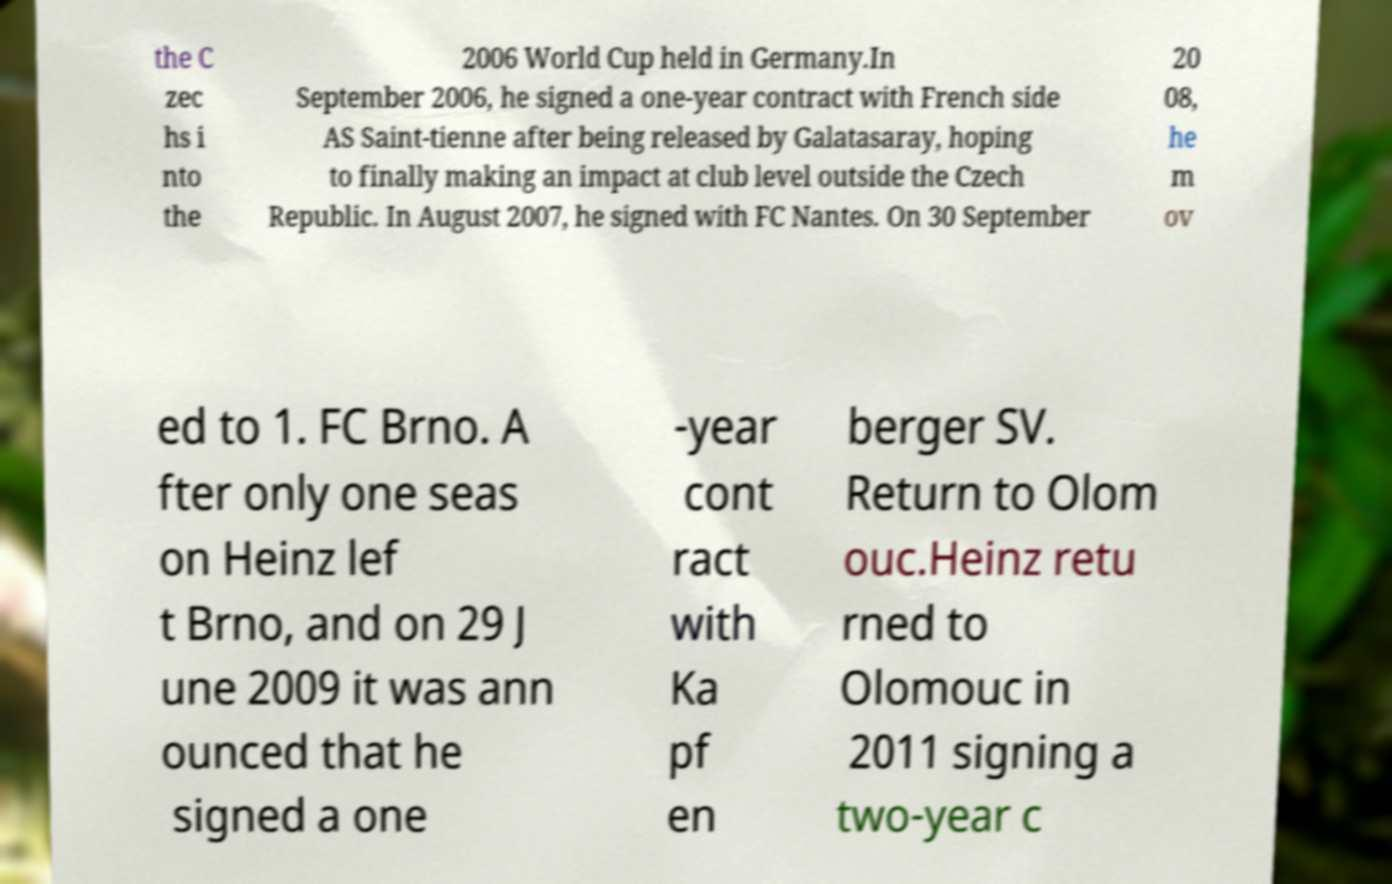What messages or text are displayed in this image? I need them in a readable, typed format. the C zec hs i nto the 2006 World Cup held in Germany.In September 2006, he signed a one-year contract with French side AS Saint-tienne after being released by Galatasaray, hoping to finally making an impact at club level outside the Czech Republic. In August 2007, he signed with FC Nantes. On 30 September 20 08, he m ov ed to 1. FC Brno. A fter only one seas on Heinz lef t Brno, and on 29 J une 2009 it was ann ounced that he signed a one -year cont ract with Ka pf en berger SV. Return to Olom ouc.Heinz retu rned to Olomouc in 2011 signing a two-year c 